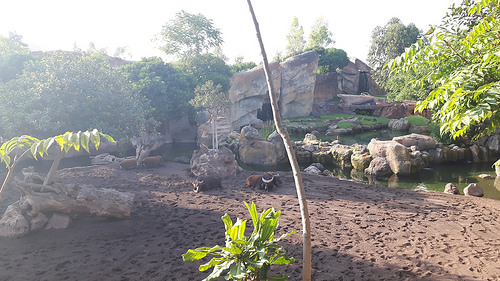<image>
Is the tree next to the sky? No. The tree is not positioned next to the sky. They are located in different areas of the scene. 